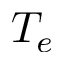<formula> <loc_0><loc_0><loc_500><loc_500>T _ { e }</formula> 